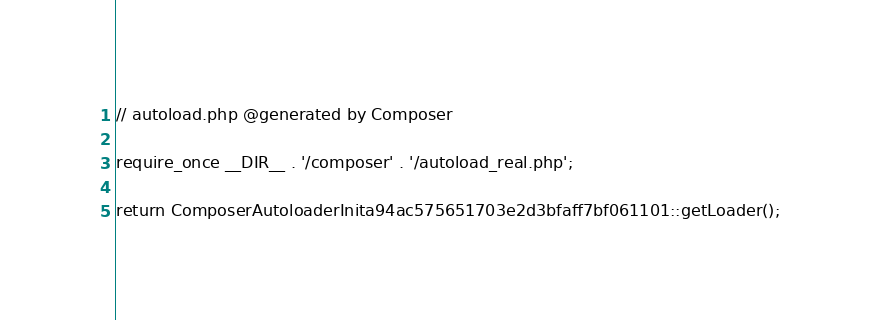Convert code to text. <code><loc_0><loc_0><loc_500><loc_500><_PHP_>
// autoload.php @generated by Composer

require_once __DIR__ . '/composer' . '/autoload_real.php';

return ComposerAutoloaderInita94ac575651703e2d3bfaff7bf061101::getLoader();
</code> 